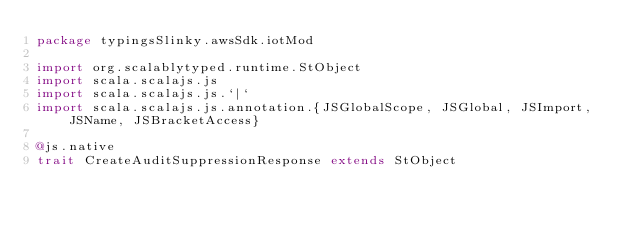Convert code to text. <code><loc_0><loc_0><loc_500><loc_500><_Scala_>package typingsSlinky.awsSdk.iotMod

import org.scalablytyped.runtime.StObject
import scala.scalajs.js
import scala.scalajs.js.`|`
import scala.scalajs.js.annotation.{JSGlobalScope, JSGlobal, JSImport, JSName, JSBracketAccess}

@js.native
trait CreateAuditSuppressionResponse extends StObject
</code> 